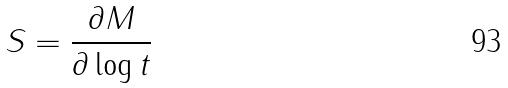Convert formula to latex. <formula><loc_0><loc_0><loc_500><loc_500>S = \frac { \partial M } { \partial \log t }</formula> 